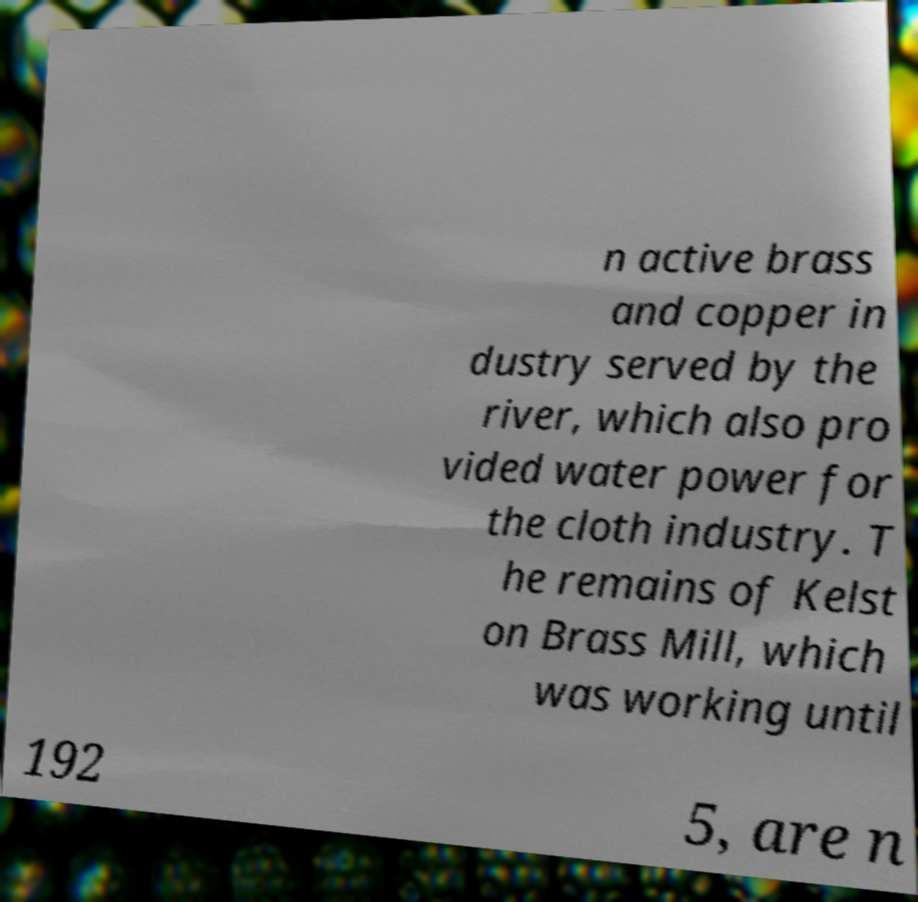I need the written content from this picture converted into text. Can you do that? n active brass and copper in dustry served by the river, which also pro vided water power for the cloth industry. T he remains of Kelst on Brass Mill, which was working until 192 5, are n 